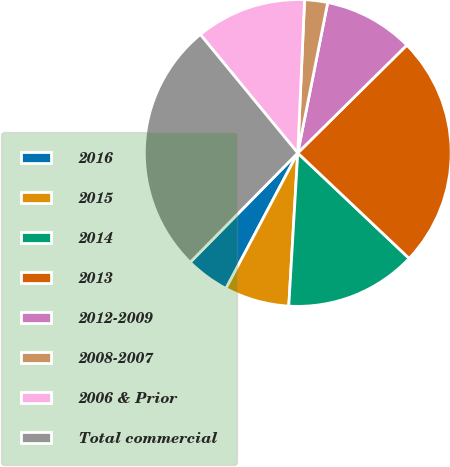Convert chart. <chart><loc_0><loc_0><loc_500><loc_500><pie_chart><fcel>2016<fcel>2015<fcel>2014<fcel>2013<fcel>2012-2009<fcel>2008-2007<fcel>2006 & Prior<fcel>Total commercial<nl><fcel>4.62%<fcel>6.82%<fcel>13.87%<fcel>24.47%<fcel>9.46%<fcel>2.42%<fcel>11.66%<fcel>26.67%<nl></chart> 